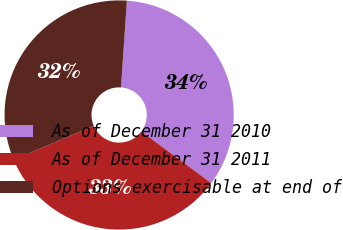Convert chart to OTSL. <chart><loc_0><loc_0><loc_500><loc_500><pie_chart><fcel>As of December 31 2010<fcel>As of December 31 2011<fcel>Options exercisable at end of<nl><fcel>34.06%<fcel>33.47%<fcel>32.47%<nl></chart> 